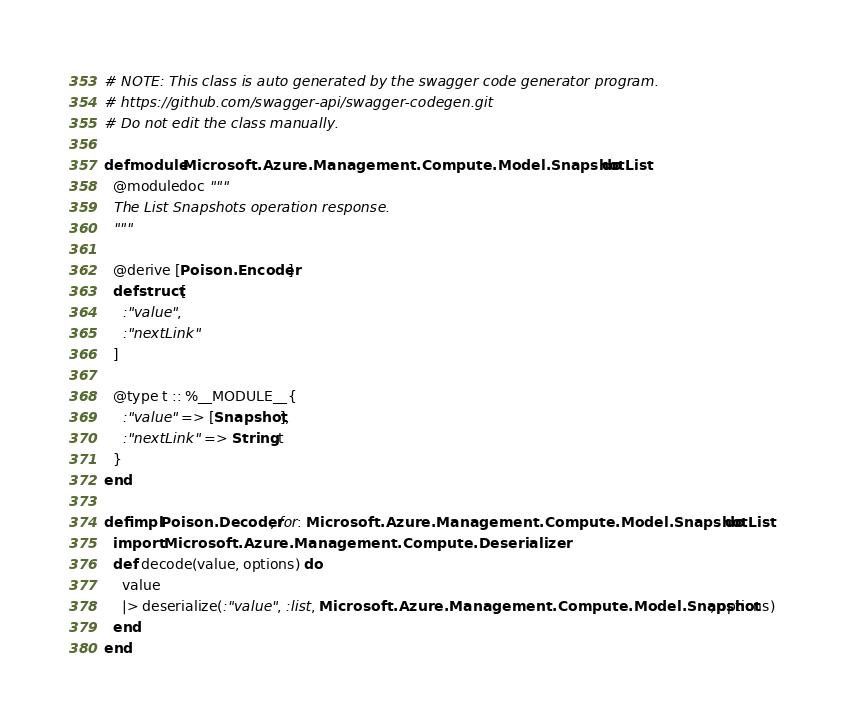<code> <loc_0><loc_0><loc_500><loc_500><_Elixir_># NOTE: This class is auto generated by the swagger code generator program.
# https://github.com/swagger-api/swagger-codegen.git
# Do not edit the class manually.

defmodule Microsoft.Azure.Management.Compute.Model.SnapshotList do
  @moduledoc """
  The List Snapshots operation response.
  """

  @derive [Poison.Encoder]
  defstruct [
    :"value",
    :"nextLink"
  ]

  @type t :: %__MODULE__{
    :"value" => [Snapshot],
    :"nextLink" => String.t
  }
end

defimpl Poison.Decoder, for: Microsoft.Azure.Management.Compute.Model.SnapshotList do
  import Microsoft.Azure.Management.Compute.Deserializer
  def decode(value, options) do
    value
    |> deserialize(:"value", :list, Microsoft.Azure.Management.Compute.Model.Snapshot, options)
  end
end

</code> 